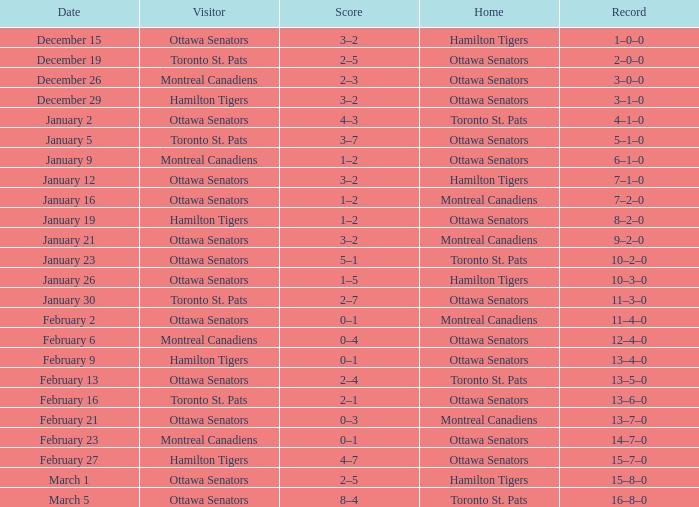What was the score on January 12? 3–2. 